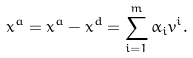<formula> <loc_0><loc_0><loc_500><loc_500>x ^ { a } = x ^ { a } - x ^ { d } = \sum _ { i = 1 } ^ { m } \alpha _ { i } v ^ { i } .</formula> 